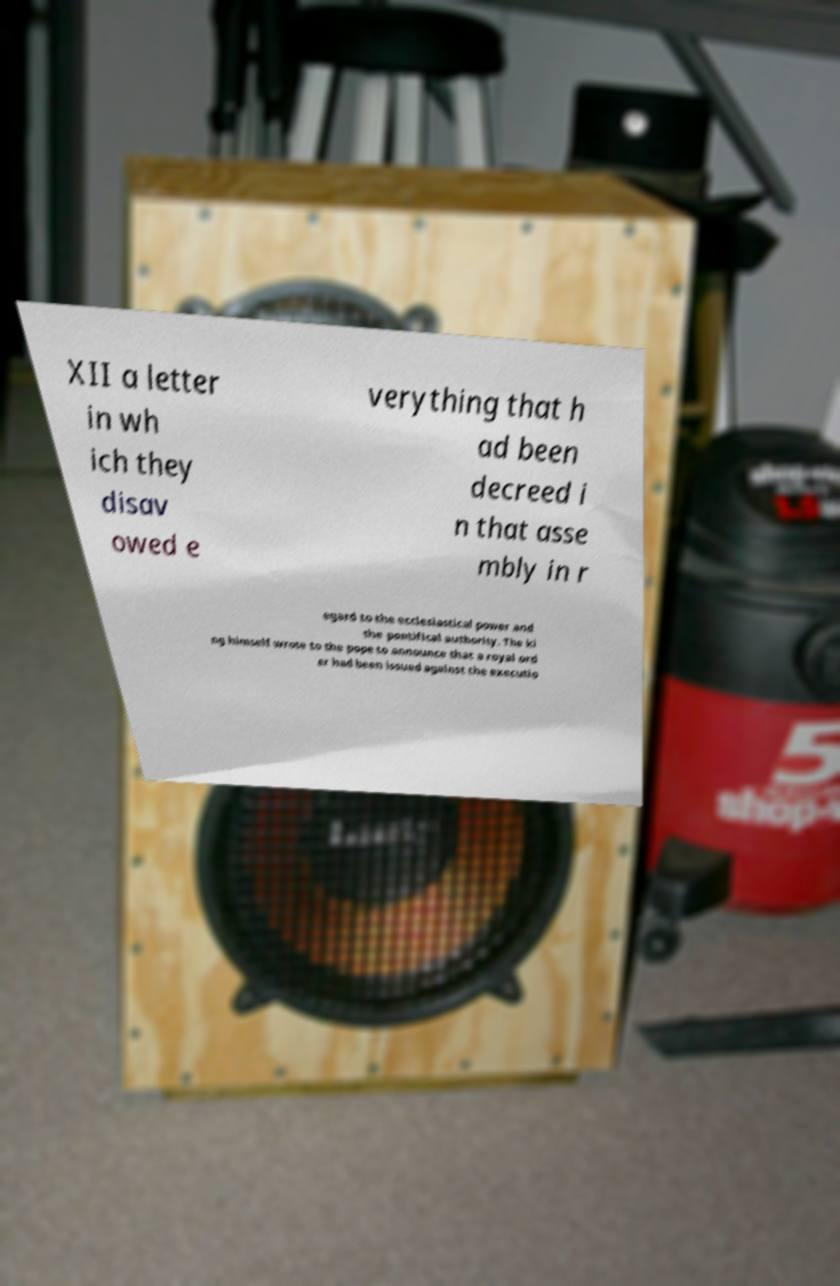Can you accurately transcribe the text from the provided image for me? XII a letter in wh ich they disav owed e verything that h ad been decreed i n that asse mbly in r egard to the ecclesiastical power and the pontifical authority. The ki ng himself wrote to the pope to announce that a royal ord er had been issued against the executio 